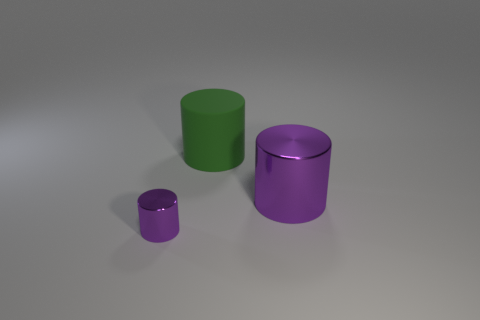What might the materials of these cylinders suggest about their use? Based on their appearance, the cylinders seem to be 3D models and not actual physical objects, suggesting they could be used for graphical design or rendering practice. If they were actual materials, the finishes could suggest different uses: a high gloss finish, like on the small purple cylinder, is often used for decorative objects because of its eye-catching shine, while a matte finish, like on the large purple cylinder, could suggest a more utilitarian object where minimizing reflection is preferable. The medium green cylinder’s semi-gloss could serve a functional purpose that also needs some level of aesthetic appeal. 